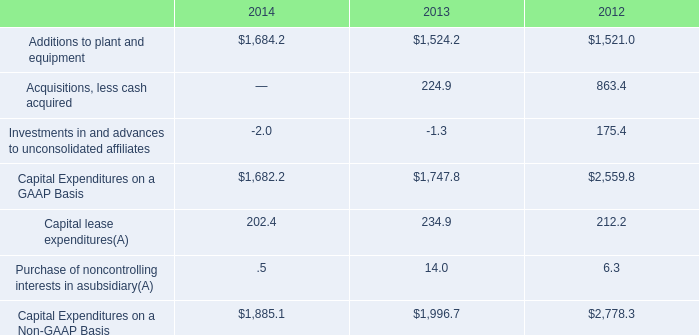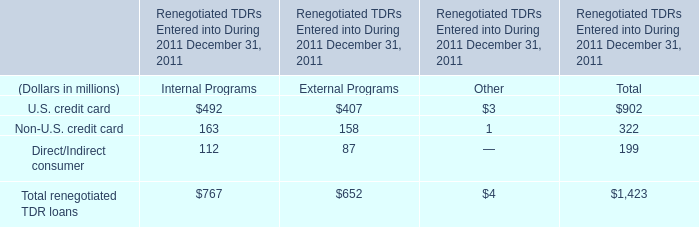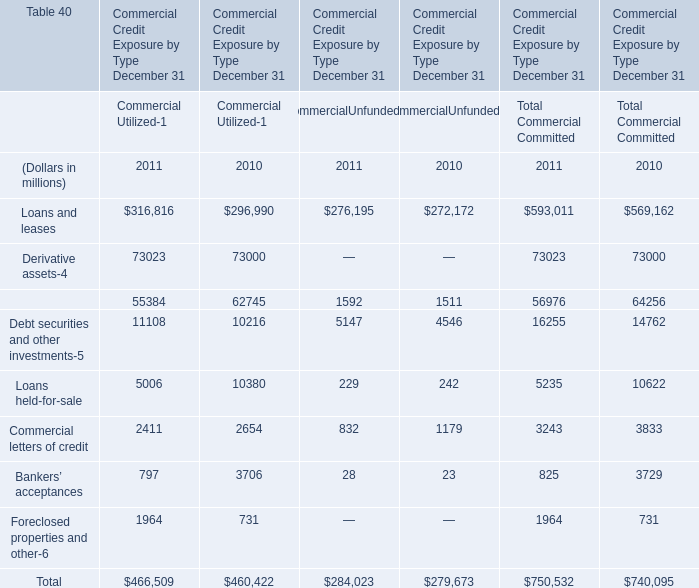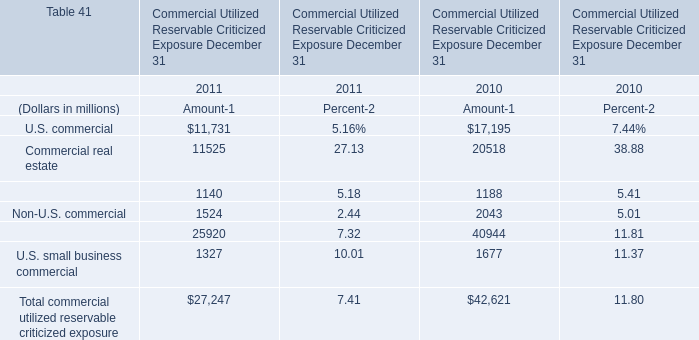What will Loans and leases reach in 2012 if it continues to grow at its current rate? (in million) 
Computations: (exp((1 + ((593011 - 569162) / 569162)) * 2))
Answer: 643748.83256. 